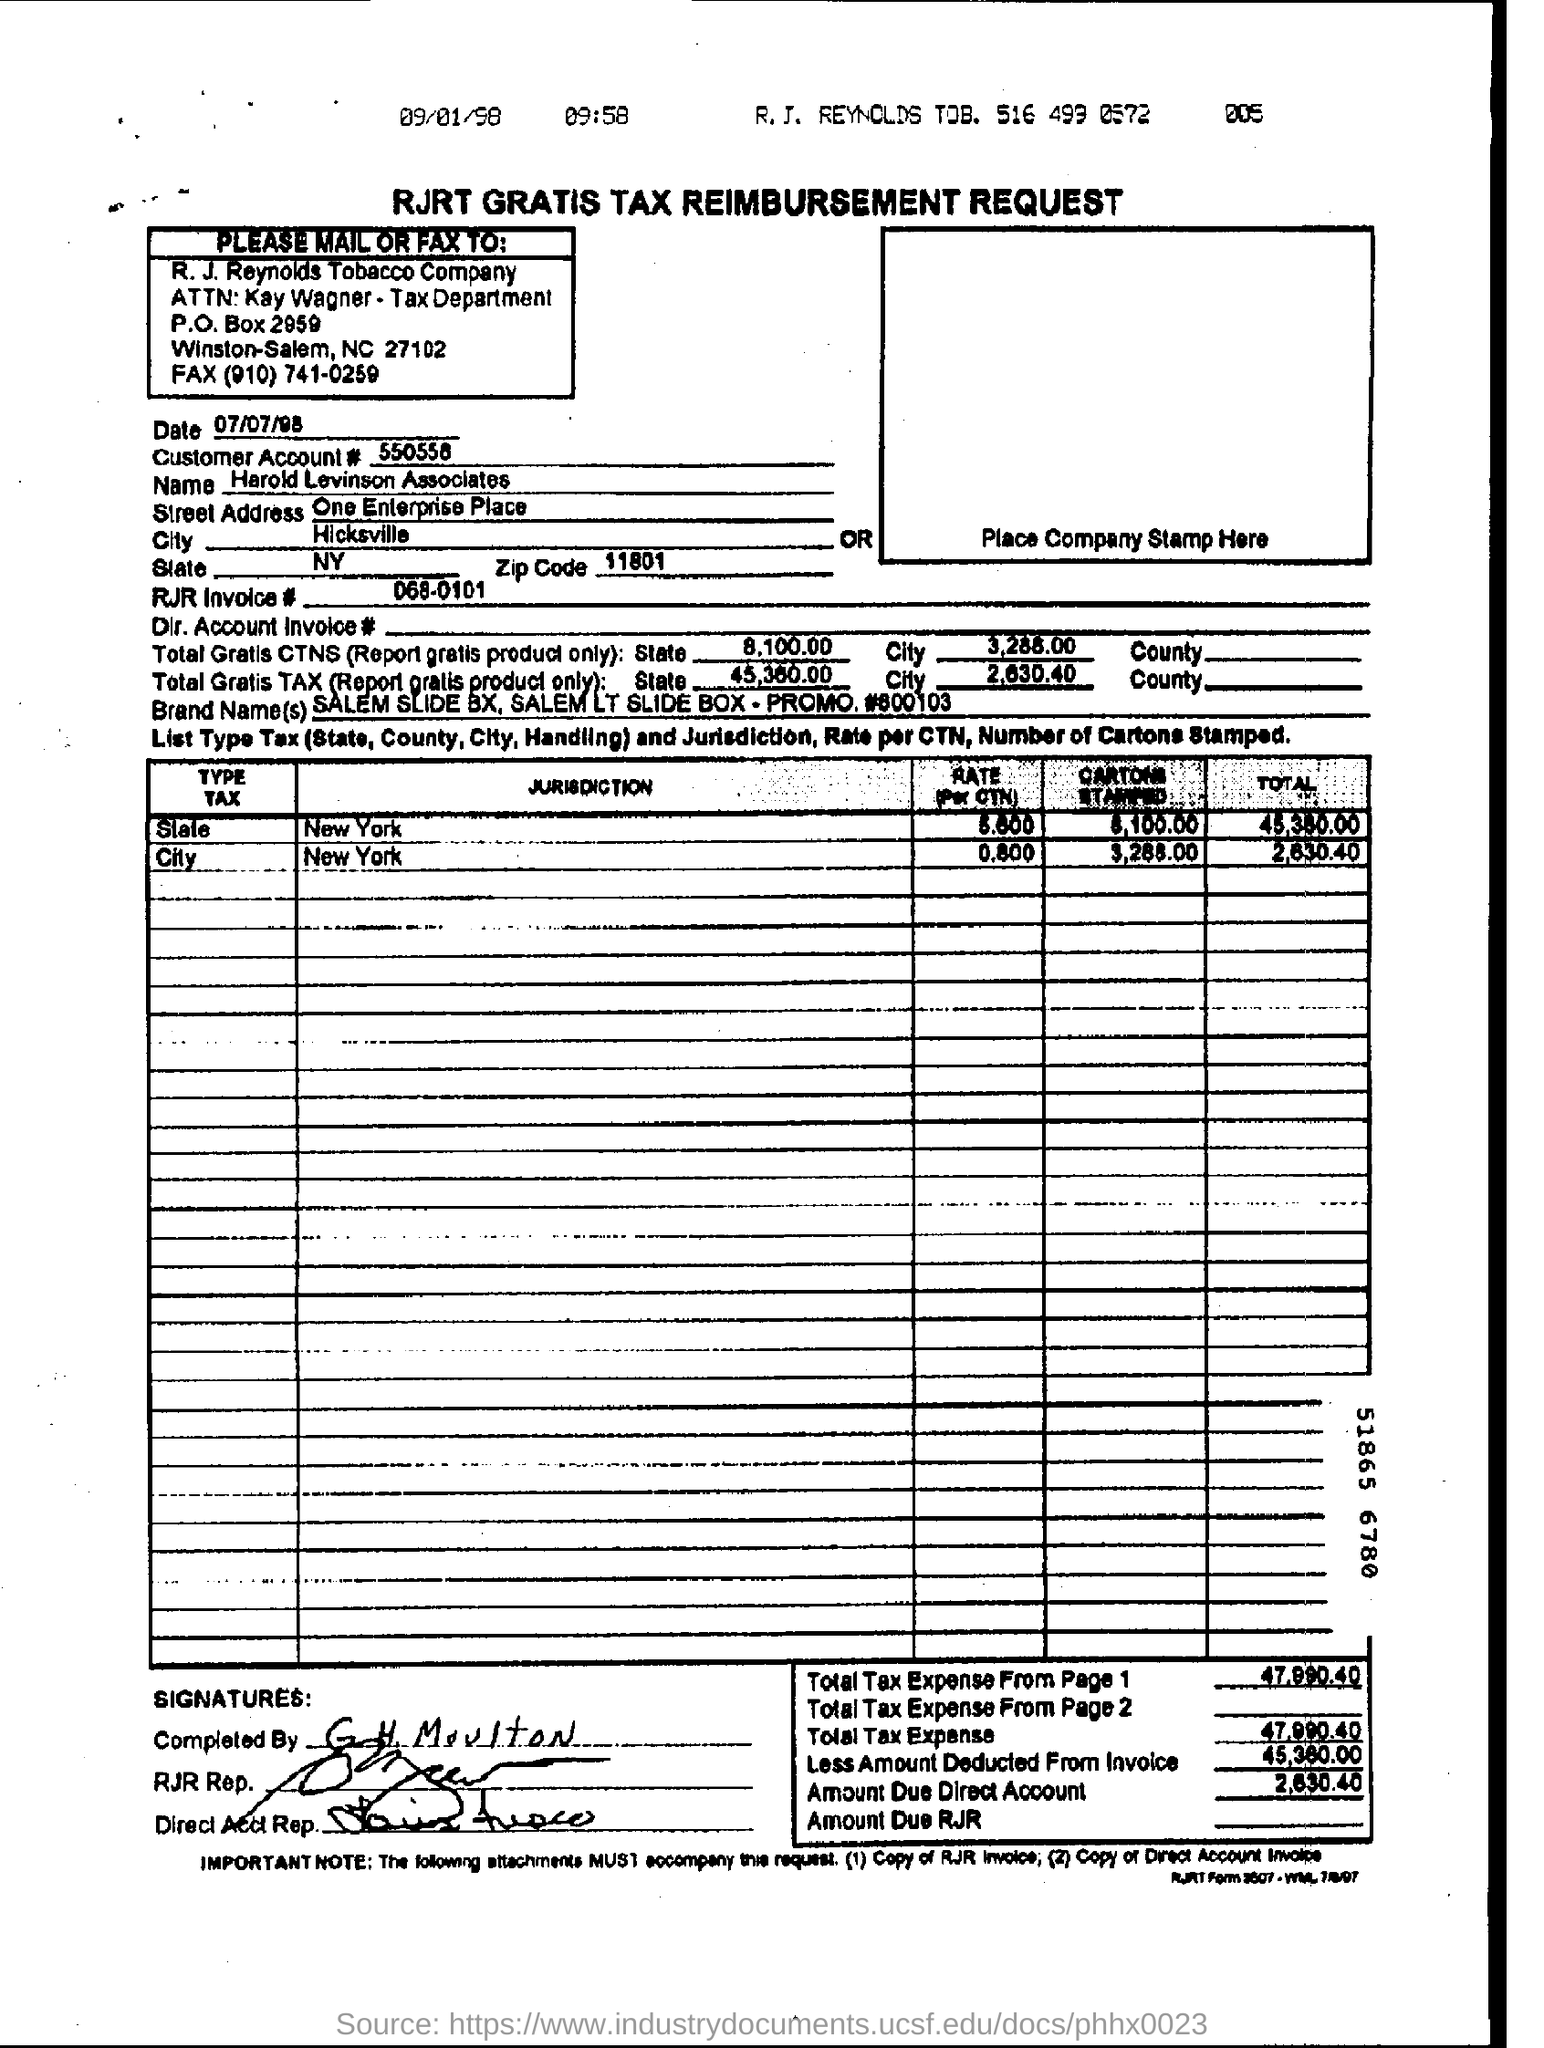Who is the tax reimbursement request form holder?
Provide a short and direct response. Harold Levinson Associates. What is the zip code mentioned in the form?
Offer a terse response. 11801. Which city is mentioned in the form?
Provide a succinct answer. Hicksville. When is the form dated?
Offer a very short reply. 07/07/98. What is the customer account number?
Ensure brevity in your answer.  550558. 